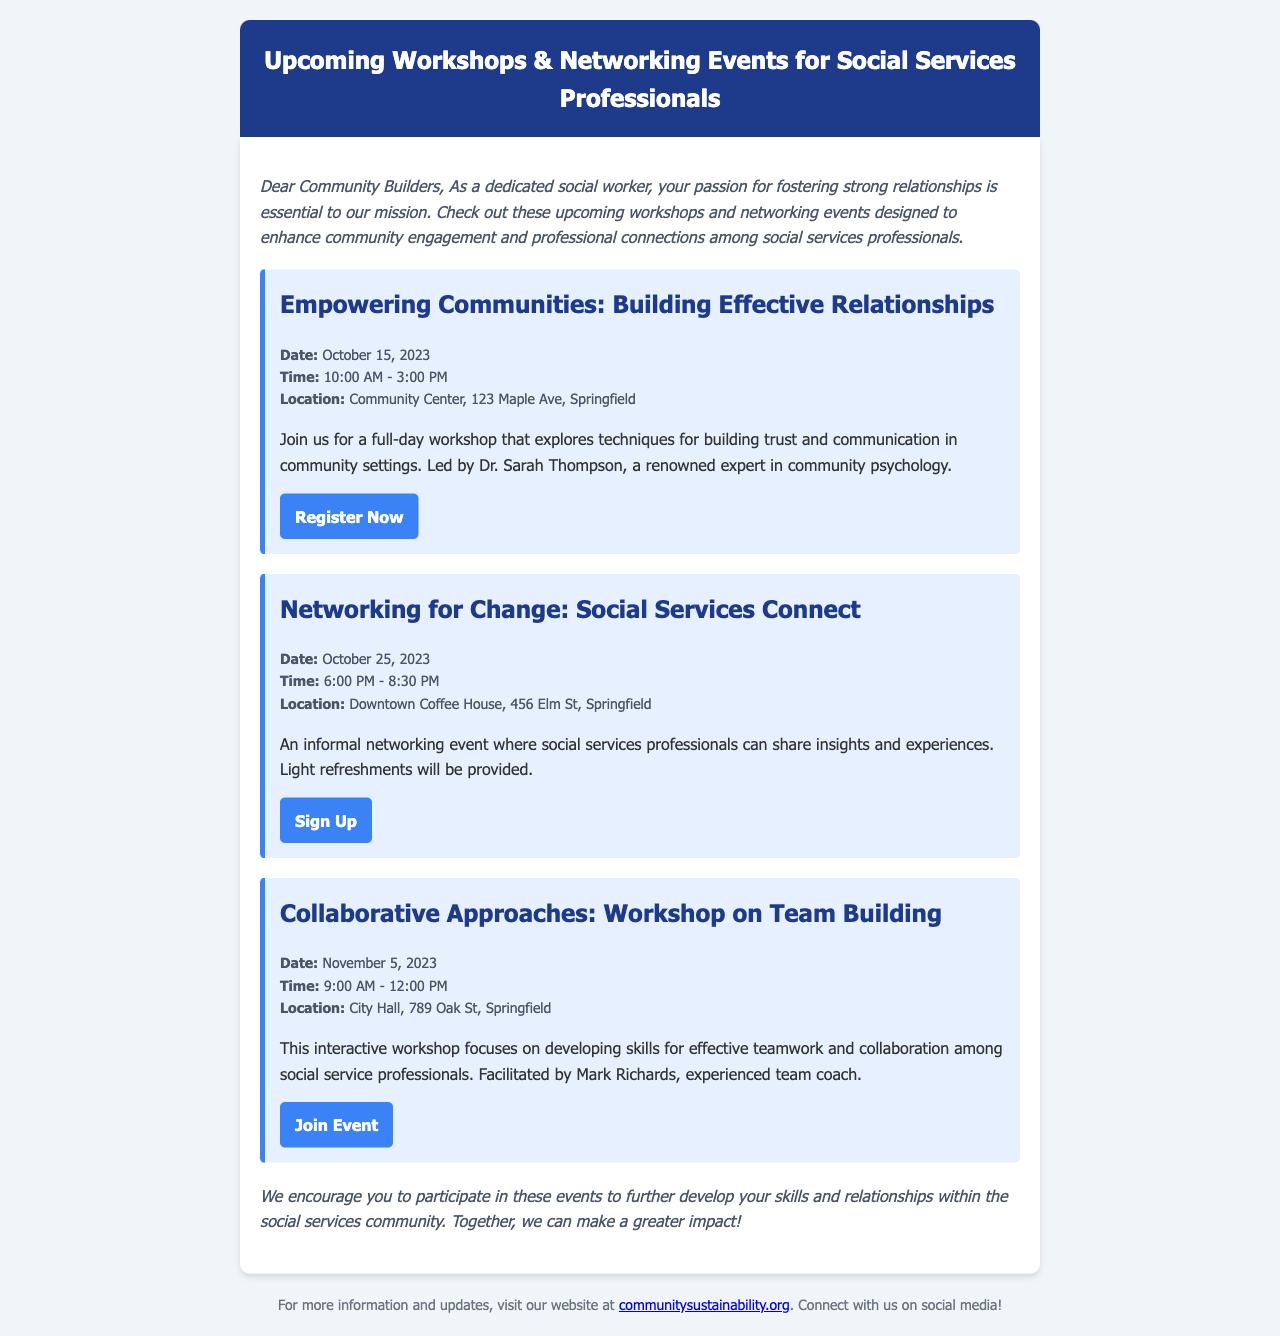What is the date of the "Empowering Communities" workshop? The date is specified in the event details of the workshop section in the document.
Answer: October 15, 2023 Who is the facilitator for the "Collaborative Approaches" workshop? The facilitator's name is mentioned in the workshop details section of the document.
Answer: Mark Richards What time does the "Networking for Change" event start? The start time is provided in the event details for the networking event in the document.
Answer: 6:00 PM What is the location of the "Empowering Communities" workshop? The location is listed in the event details of the workshop section in the document.
Answer: Community Center, 123 Maple Ave, Springfield What type of event is "Networking for Change"? Type is inferred from the description of the event provided in the document.
Answer: Informal networking event How long is the "Collaborative Approaches" workshop? The duration is derived from the time frame mentioned in the event details for the workshop.
Answer: 3 hours What is the main focus of the "Empowering Communities" workshop? The main focus is highlighted in the descriptive paragraph of the workshop in the document.
Answer: Building trust and communication What is provided at the "Networking for Change" event? The information is mentioned in the event details regarding refreshments.
Answer: Light refreshments What is the purpose of the newsletter? The purpose is indicated in the introduction section of the document.
Answer: Enhance community engagement and professional connections 